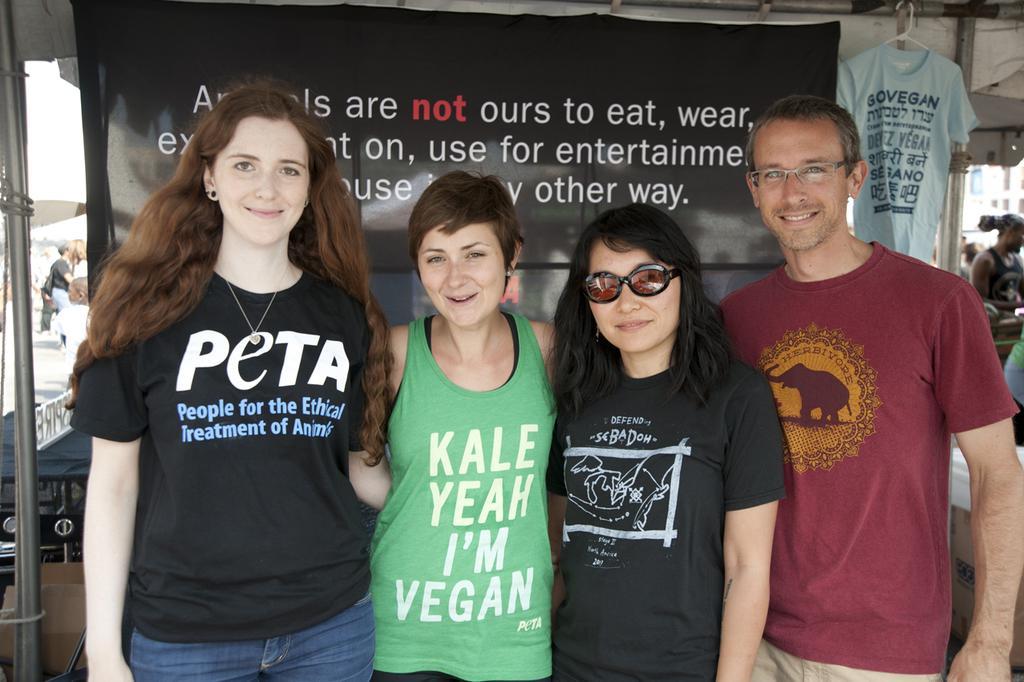In one or two sentences, can you explain what this image depicts? There are three women and a man standing and behind them we can see a banner and a t-shirt hanging to a pole. On the left side we can see few persons,sky and other objects and on the right side we can see few persons and a building. 